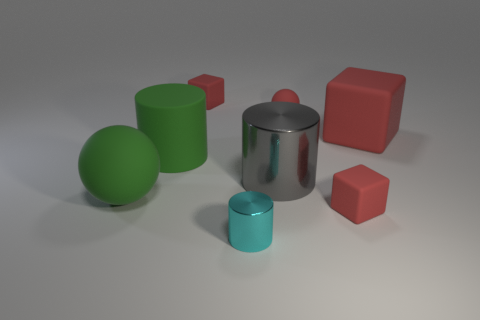Subtract all red cubes. How many were subtracted if there are1red cubes left? 2 Subtract all small blocks. How many blocks are left? 1 Add 1 purple blocks. How many objects exist? 9 Subtract all gray cylinders. How many cylinders are left? 2 Subtract all cyan spheres. Subtract all gray cubes. How many spheres are left? 2 Add 3 big red matte cubes. How many big red matte cubes exist? 4 Subtract 1 red spheres. How many objects are left? 7 Subtract all balls. How many objects are left? 6 Subtract 1 spheres. How many spheres are left? 1 Subtract all purple spheres. How many purple cylinders are left? 0 